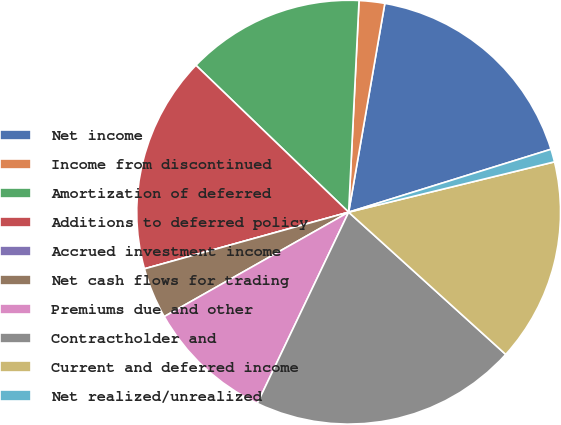Convert chart to OTSL. <chart><loc_0><loc_0><loc_500><loc_500><pie_chart><fcel>Net income<fcel>Income from discontinued<fcel>Amortization of deferred<fcel>Additions to deferred policy<fcel>Accrued investment income<fcel>Net cash flows for trading<fcel>Premiums due and other<fcel>Contractholder and<fcel>Current and deferred income<fcel>Net realized/unrealized<nl><fcel>17.47%<fcel>1.95%<fcel>13.59%<fcel>16.5%<fcel>0.0%<fcel>3.89%<fcel>9.71%<fcel>20.38%<fcel>15.53%<fcel>0.98%<nl></chart> 